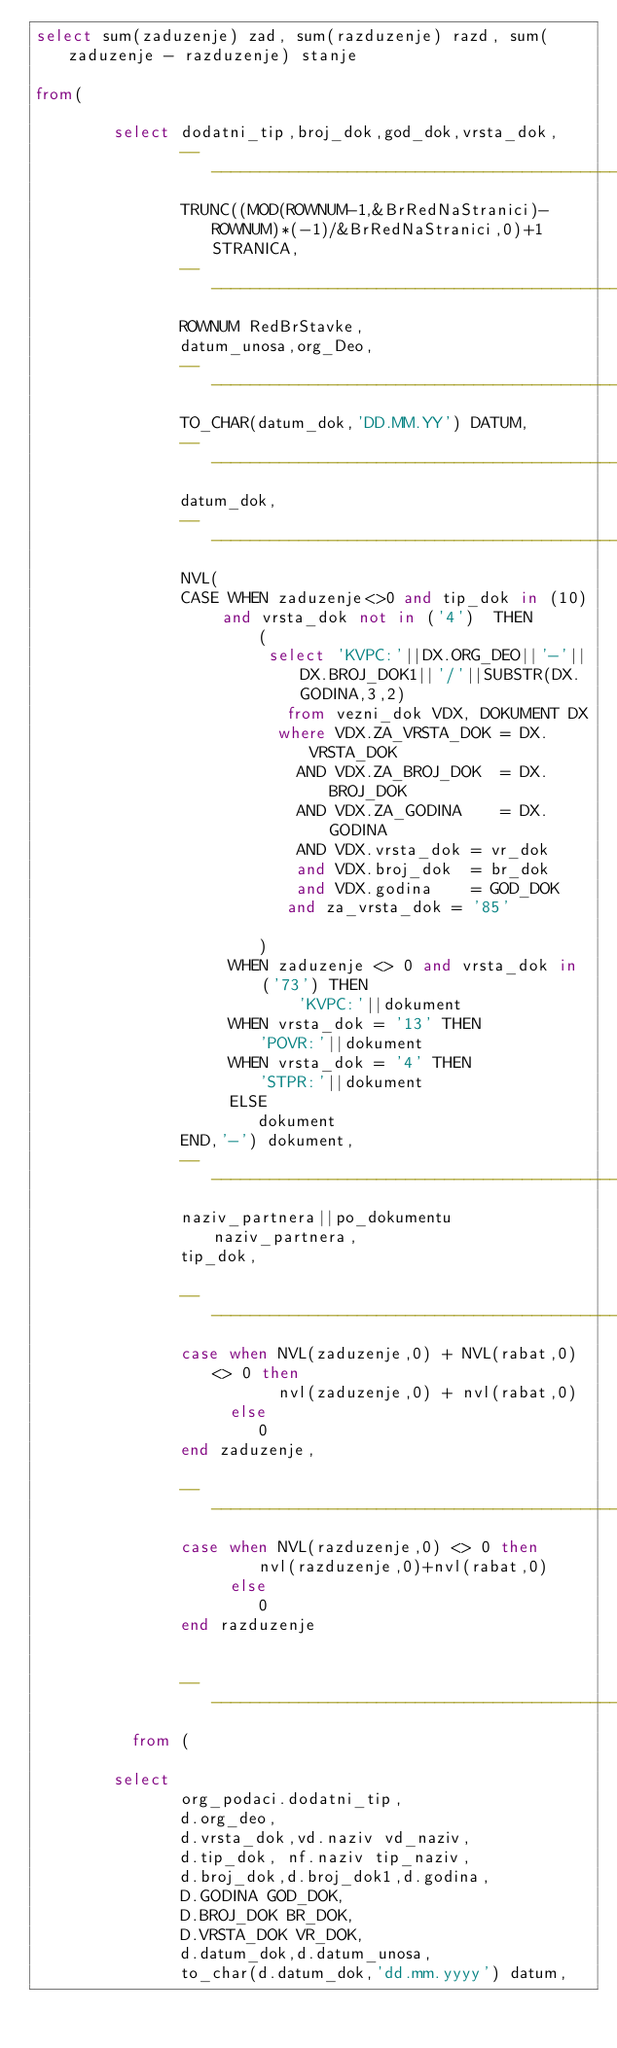<code> <loc_0><loc_0><loc_500><loc_500><_SQL_>select sum(zaduzenje) zad, sum(razduzenje) razd, sum(zaduzenje - razduzenje) stanje

from(

        select dodatni_tip,broj_dok,god_dok,vrsta_dok,
               --------------------------------------------------------------------------------------------
               TRUNC((MOD(ROWNUM-1,&BrRedNaStranici)-ROWNUM)*(-1)/&BrRedNaStranici,0)+1 STRANICA,
               --------------------------------------------------------------------------------------------
               ROWNUM RedBrStavke,
               datum_unosa,org_Deo,
               --------------------------------------------------------------------------------------------
               TO_CHAR(datum_dok,'DD.MM.YY') DATUM,
               --------------------------------------------------------------------------------------------
               datum_dok,
               --------------------------------------------------------------------------------------------
               NVL(
               CASE WHEN zaduzenje<>0 and tip_dok in (10) and vrsta_dok not in ('4')  THEN
                       (
                        select 'KVPC:'||DX.ORG_DEO||'-'||DX.BROJ_DOK1||'/'||SUBSTR(DX.GODINA,3,2)
                          from vezni_dok VDX, DOKUMENT DX
                         where VDX.ZA_VRSTA_DOK = DX.VRSTA_DOK
                           AND VDX.ZA_BROJ_DOK  = DX.BROJ_DOK
                           AND VDX.ZA_GODINA    = DX.GODINA
                           AND VDX.vrsta_dok = vr_dok
                           and VDX.broj_dok  = br_dok
                           and VDX.godina    = GOD_DOK
                          and za_vrsta_dok = '85'

                       )
                    WHEN zaduzenje <> 0 and vrsta_dok in ('73') THEN
                           'KVPC:'||dokument
                    WHEN vrsta_dok = '13' THEN
                       'POVR:'||dokument
                    WHEN vrsta_dok = '4' THEN
                       'STPR:'||dokument
                    ELSE
                       dokument
               END,'-') dokument,
               --------------------------------------------------------------------------------------------
               naziv_partnera||po_dokumentu naziv_partnera,
               tip_dok,

               --------------------------------------------------------------------------------------------
               case when NVL(zaduzenje,0) + NVL(rabat,0) <> 0 then
                         nvl(zaduzenje,0) + nvl(rabat,0)
                    else
                       0
               end zaduzenje,

               --------------------------------------------------------------------------------------------
               case when NVL(razduzenje,0) <> 0 then
                       nvl(razduzenje,0)+nvl(rabat,0)
                    else
                       0
               end razduzenje


               --------------------------------------------------------------------------------------------
          from (

        select
               org_podaci.dodatni_tip,
               d.org_deo,
               d.vrsta_dok,vd.naziv vd_naziv,
               d.tip_dok, nf.naziv tip_naziv,
               d.broj_dok,d.broj_dok1,d.godina,
               D.GODINA GOD_DOK,
               D.BROJ_DOK BR_DOK,
               D.VRSTA_DOK VR_DOK,
               d.datum_dok,d.datum_unosa,
               to_char(d.datum_dok,'dd.mm.yyyy') datum,</code> 